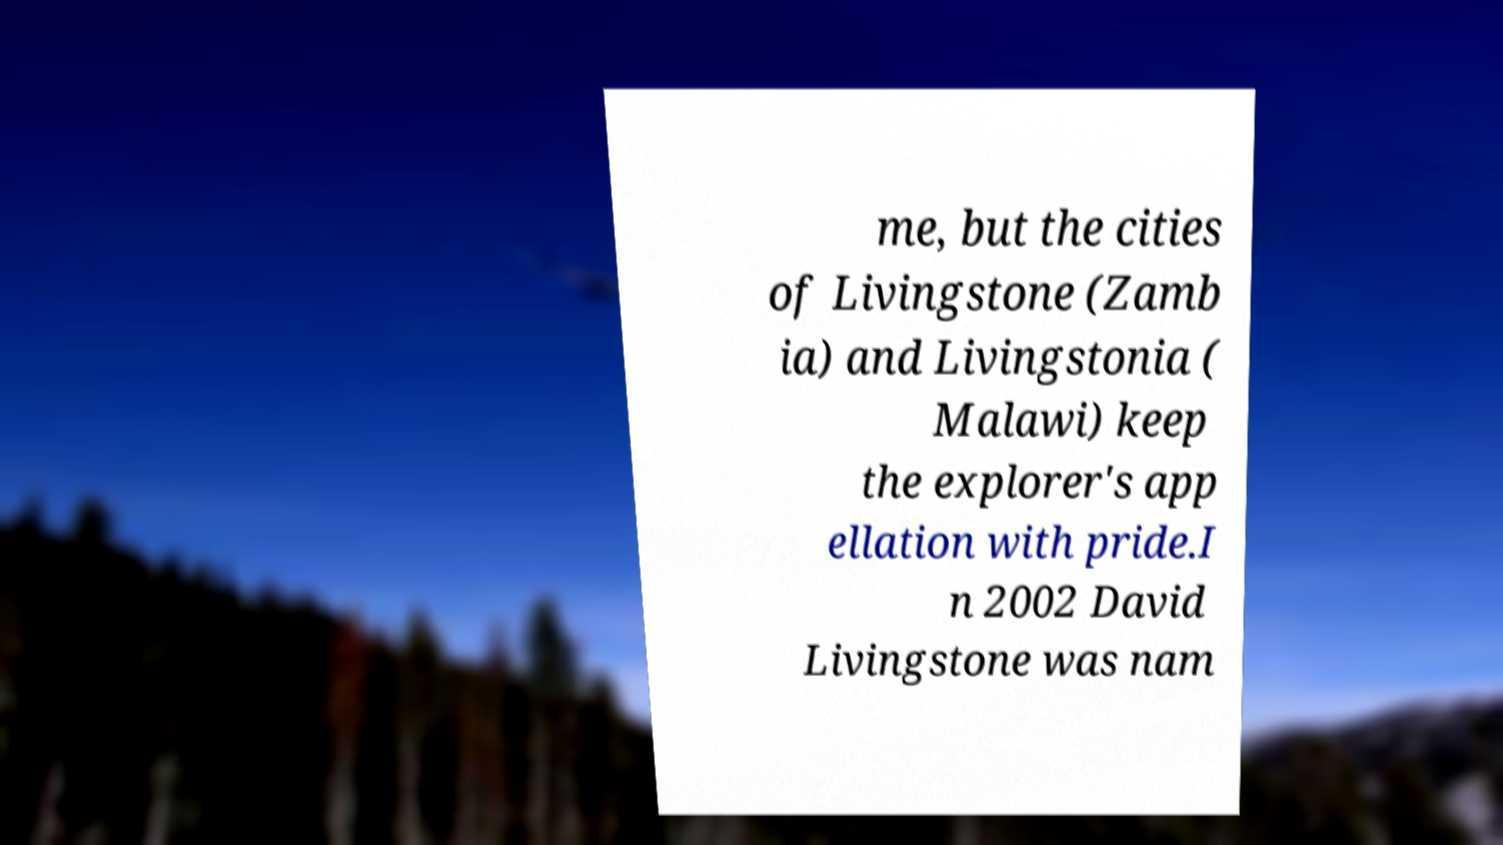There's text embedded in this image that I need extracted. Can you transcribe it verbatim? me, but the cities of Livingstone (Zamb ia) and Livingstonia ( Malawi) keep the explorer's app ellation with pride.I n 2002 David Livingstone was nam 